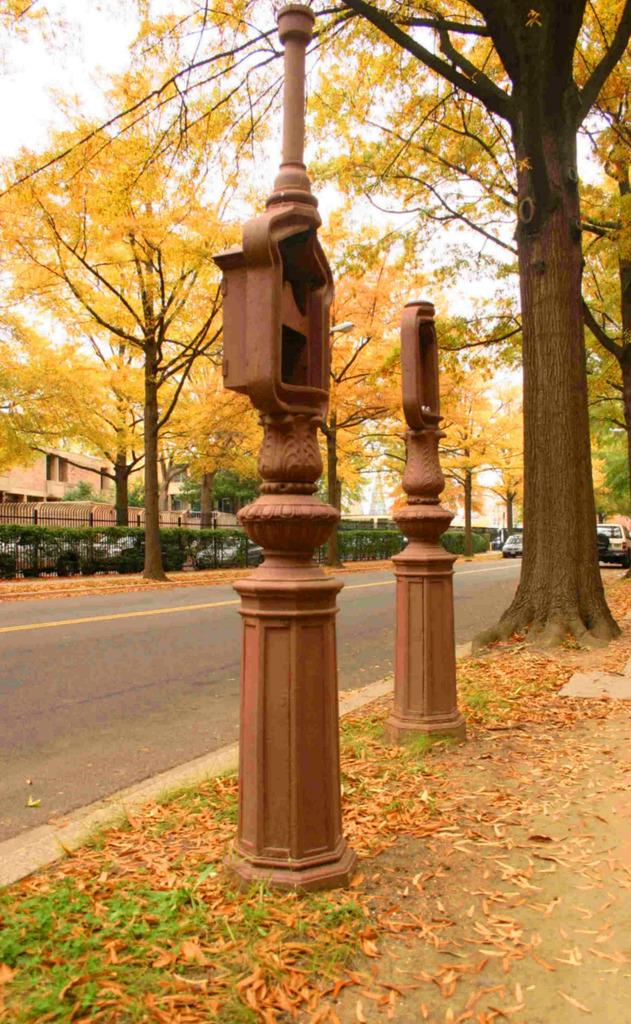What structures can be seen in the image? There are poles and buildings visible in the image. What type of vegetation is present in the image? There are trees and shredded leaves in the image. What is used for cooking in the image? Grills are present in the image for cooking. What type of transportation is on the road in the image? Motor vehicles are on the road in the image. What can be seen in the background of the image? The sky is visible in the background of the image. How does the ocean affect the landscape in the image? There is no ocean present in the image; it features poles, trees, buildings, grills, motor vehicles, and the sky. What type of dust can be seen covering the leaves in the image? There is no dust present in the image; it features shredded leaves. 